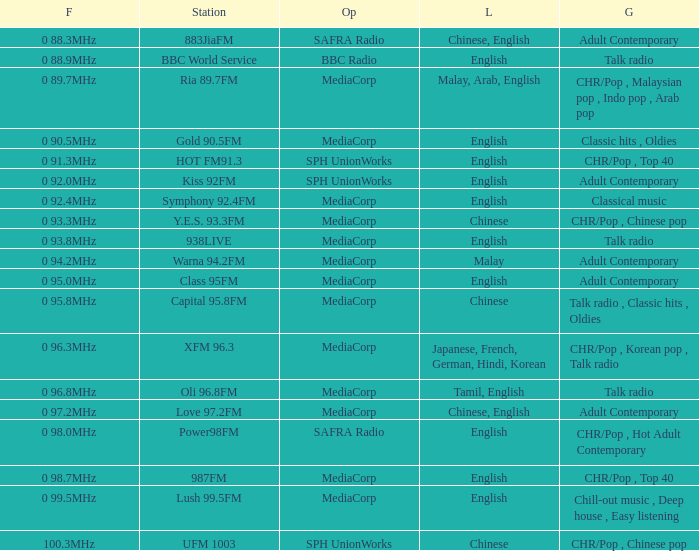Can you identify the genre of the bbc world service? Talk radio. 